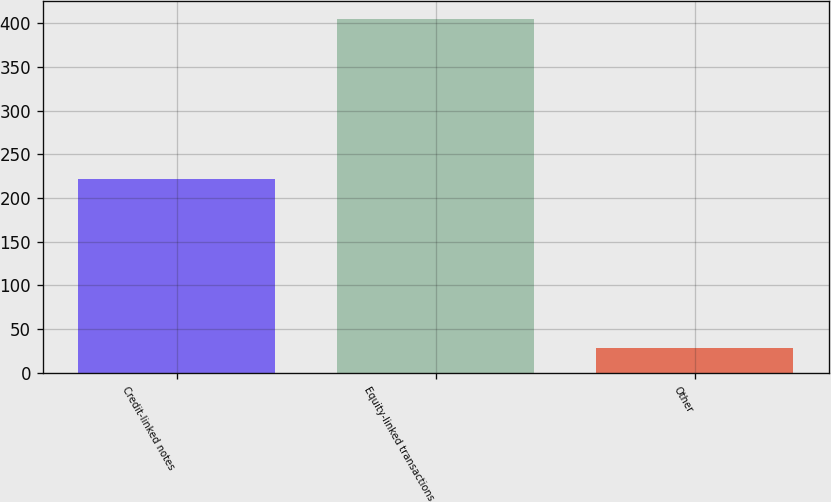Convert chart to OTSL. <chart><loc_0><loc_0><loc_500><loc_500><bar_chart><fcel>Credit-linked notes<fcel>Equity-linked transactions<fcel>Other<nl><fcel>222<fcel>405<fcel>28<nl></chart> 